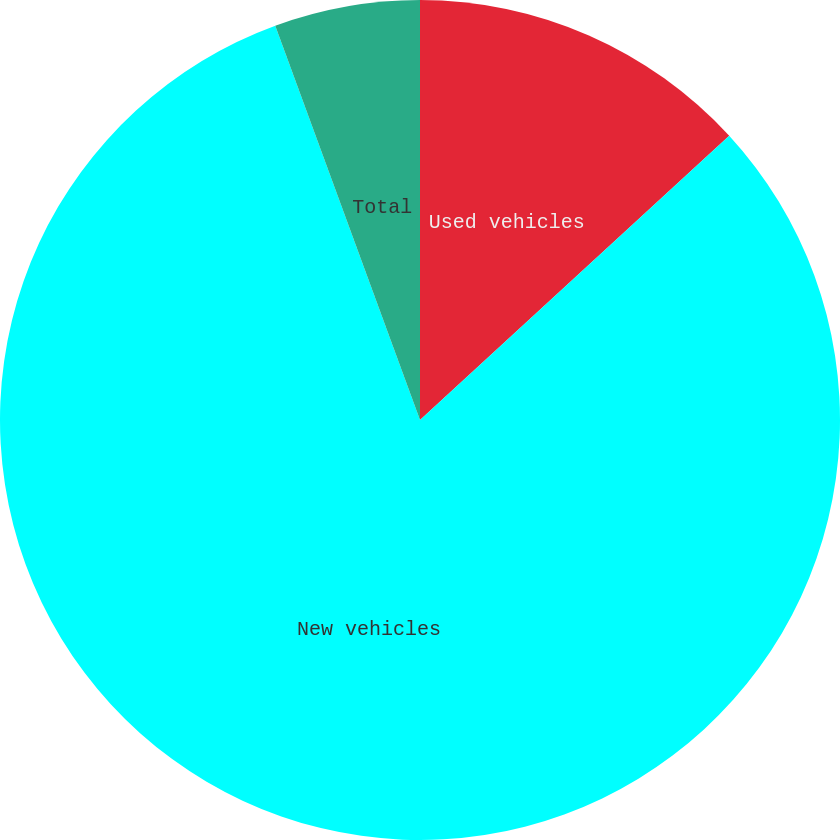Convert chart to OTSL. <chart><loc_0><loc_0><loc_500><loc_500><pie_chart><fcel>Used vehicles<fcel>New vehicles<fcel>Total<nl><fcel>13.17%<fcel>81.23%<fcel>5.6%<nl></chart> 